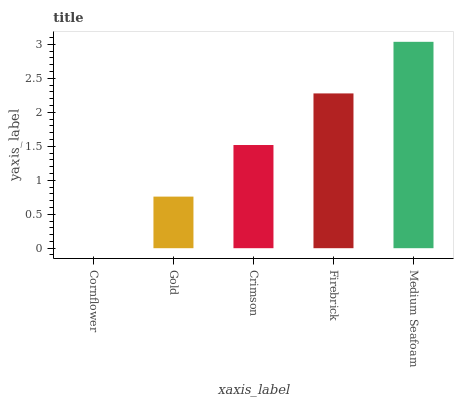Is Cornflower the minimum?
Answer yes or no. Yes. Is Medium Seafoam the maximum?
Answer yes or no. Yes. Is Gold the minimum?
Answer yes or no. No. Is Gold the maximum?
Answer yes or no. No. Is Gold greater than Cornflower?
Answer yes or no. Yes. Is Cornflower less than Gold?
Answer yes or no. Yes. Is Cornflower greater than Gold?
Answer yes or no. No. Is Gold less than Cornflower?
Answer yes or no. No. Is Crimson the high median?
Answer yes or no. Yes. Is Crimson the low median?
Answer yes or no. Yes. Is Firebrick the high median?
Answer yes or no. No. Is Cornflower the low median?
Answer yes or no. No. 